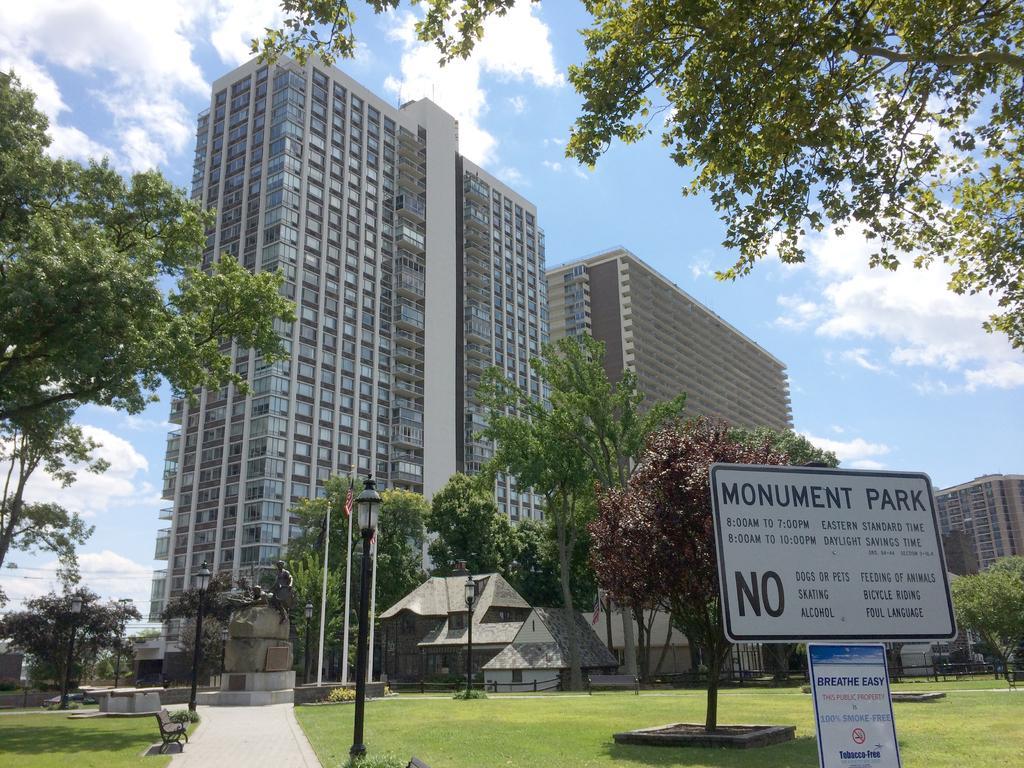Describe this image in one or two sentences. In this image we can see a board with some text on it. There are trees. There is a statue. There are light poles. In the background of the image there is sky, clouds. There are buildings. At the bottom of the image there is grass and pavement. 